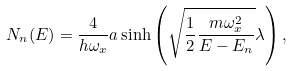Convert formula to latex. <formula><loc_0><loc_0><loc_500><loc_500>N _ { n } ( E ) = \frac { 4 } { h \omega _ { x } } a \sinh \left ( \sqrt { \frac { 1 } { 2 } \frac { m \omega _ { x } ^ { 2 } } { E - E _ { n } } } \lambda \right ) ,</formula> 